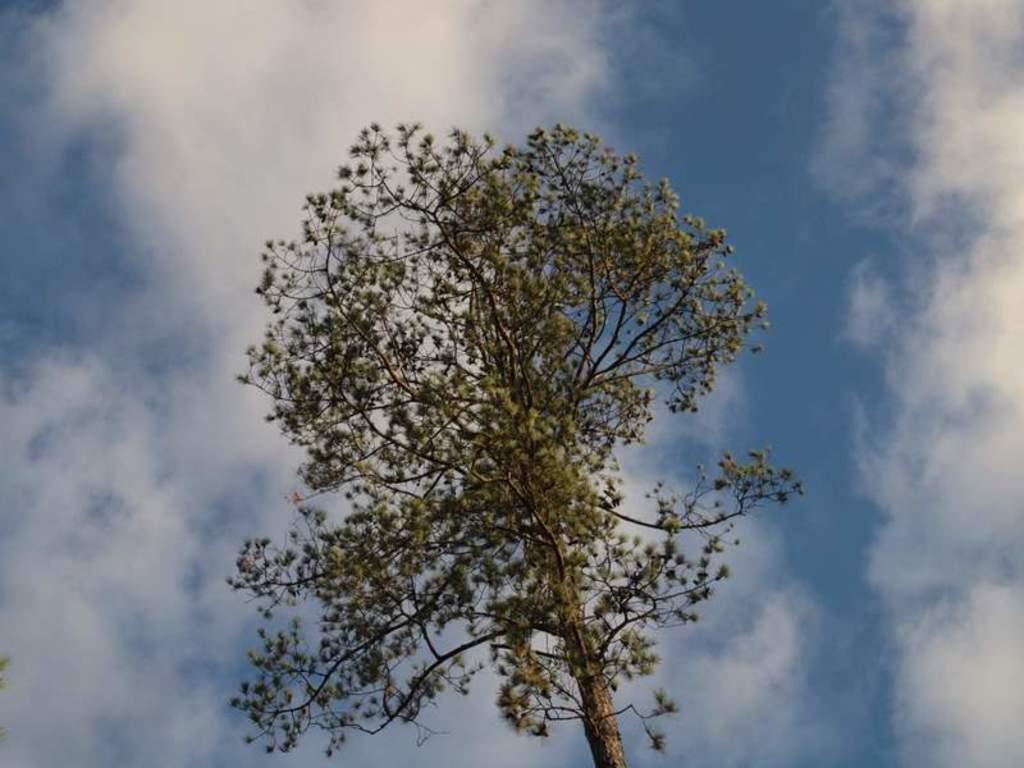What type of natural object can be seen in the image? There is a tree in the image. What else is visible in the sky in the image? There are clouds visible in the image. What part of the natural environment is visible in the image? The sky is visible in the background of the image. What type of organization is depicted in the image? There is no organization present in the image; it features a tree and clouds. What type of mineral can be seen in the image? There is no mineral present in the image. What type of note is visible in the image? There is no note present in the image. 